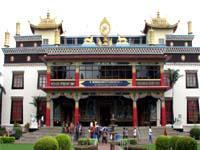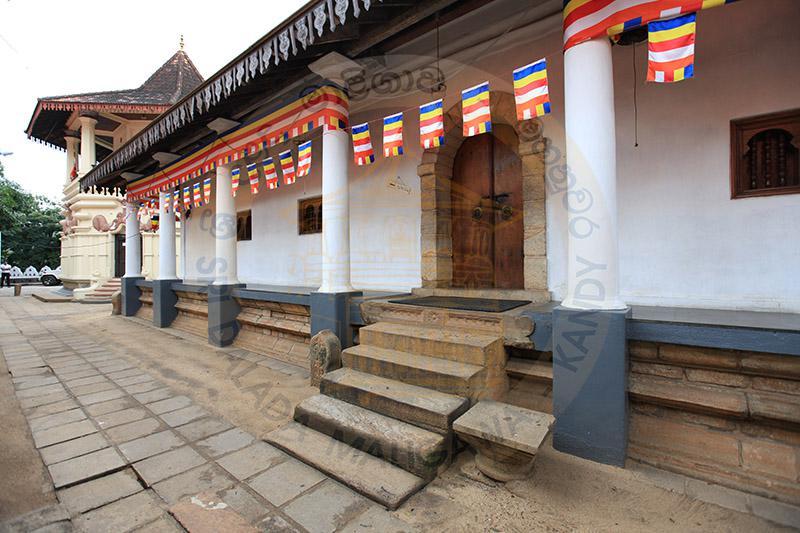The first image is the image on the left, the second image is the image on the right. For the images shown, is this caption "There is at least one flag in front the building in at least one of the images." true? Answer yes or no. Yes. The first image is the image on the left, the second image is the image on the right. Considering the images on both sides, is "Each image shows an ornate building with a series of posts that support a roof hanging over a walkway that allows access to an entrance." valid? Answer yes or no. Yes. 